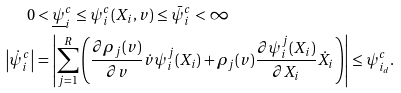<formula> <loc_0><loc_0><loc_500><loc_500>0 & < \underline { \psi } _ { i } ^ { c } \leq \psi _ { i } ^ { c } ( X _ { i } , v ) \leq \bar { \psi } _ { i } ^ { c } < \infty \\ \left | \dot { \psi } _ { i } ^ { c } \right | & = \left | \sum _ { j = 1 } ^ { R } \left ( \frac { \partial \rho _ { j } ( v ) } { \partial v } \dot { v } \psi _ { i } ^ { j } ( X _ { i } ) + \rho _ { j } ( v ) \frac { \partial \psi _ { i } ^ { j } ( X _ { i } ) } { \partial X _ { i } } \dot { X } _ { i } \right ) \right | \leq \psi _ { i _ { d } } ^ { c } .</formula> 